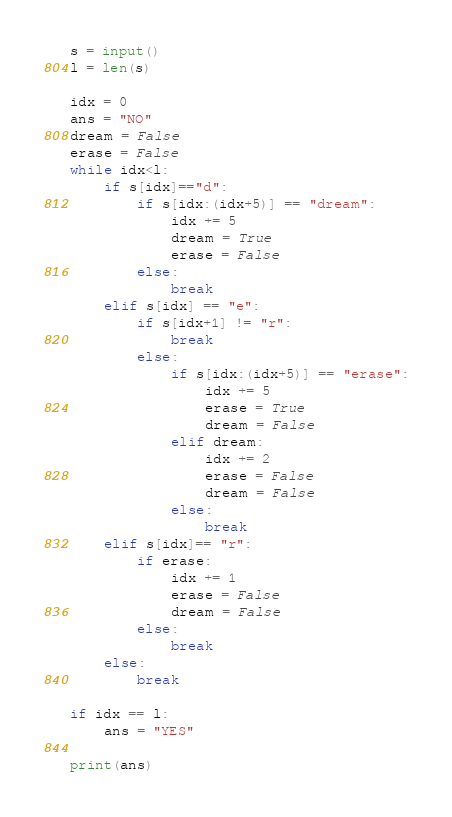<code> <loc_0><loc_0><loc_500><loc_500><_Python_>s = input()
l = len(s)

idx = 0
ans = "NO"
dream = False
erase = False
while idx<l:
    if s[idx]=="d":
        if s[idx:(idx+5)] == "dream":
            idx += 5
            dream = True
            erase = False
        else:
            break
    elif s[idx] == "e":
        if s[idx+1] != "r":
            break
        else:
            if s[idx:(idx+5)] == "erase":
                idx += 5
                erase = True
                dream = False
            elif dream:
                idx += 2
                erase = False
                dream = False
            else:
                break
    elif s[idx]== "r":
        if erase:
            idx += 1
            erase = False
            dream = False
        else:
            break
    else:
        break

if idx == l:
    ans = "YES"

print(ans)</code> 